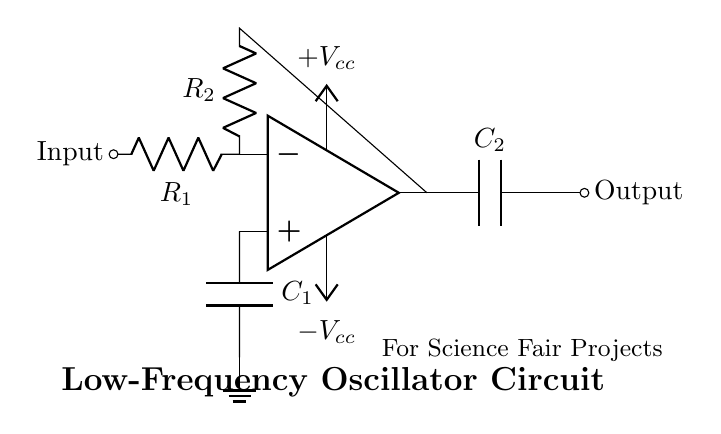What is the function of the op-amp in this circuit? The op-amp functions as the amplifier in the oscillator circuit, which is crucial for generating oscillations. It amplifies the input voltage and helps to create the feedback necessary for oscillation.
Answer: amplifier What type of capacitors are used in the circuit? The circuit uses two capacitors, labeled as C1 and C2, which are both electrolytic capacitors typically used for timing functions in oscillators.
Answer: electrolytic How many resistors are present in the circuit? There are two resistors, R1 and R2, which are used to set the gain and determine the frequency of oscillation.
Answer: two What are the supply voltages for this oscillator circuit? The op-amp uses a positive and a negative supply voltage labeled as Vcc and -Vcc, providing the necessary power for the op-amp to operate.
Answer: plus Vcc and minus Vcc What is the significance of the capacitors in this oscillator circuit? The capacitors are fundamental for timing and frequency generation; they charge and discharge to create oscillations, thus determining the frequency of the output signal.
Answer: timing and frequency generation What would happen if one of the resistors is removed? Removing one of the resistors would disrupt the feedback loop necessary for oscillation, potentially preventing the circuit from operating properly.
Answer: circuit may not oscillate 